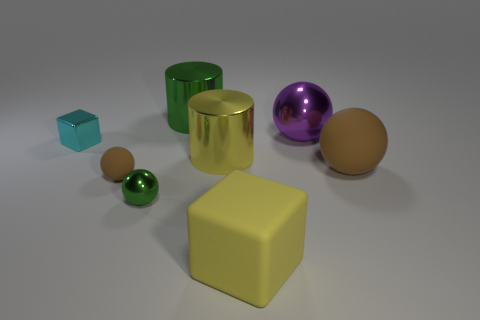What number of objects are things to the right of the big green metal cylinder or tiny green metallic balls?
Your answer should be very brief. 5. Does the big ball behind the big matte ball have the same color as the large matte sphere?
Provide a short and direct response. No. The green metal thing that is behind the ball behind the tiny cyan metallic thing is what shape?
Offer a terse response. Cylinder. Is the number of large purple balls right of the purple thing less than the number of cyan shiny things in front of the metallic block?
Your answer should be very brief. No. There is a green object that is the same shape as the small brown matte thing; what size is it?
Provide a short and direct response. Small. Are there any other things that are the same size as the cyan metal block?
Your answer should be very brief. Yes. How many things are big cylinders that are behind the tiny cyan shiny block or big metal cylinders behind the small cyan metal thing?
Offer a very short reply. 1. Is the size of the cyan metallic object the same as the green ball?
Provide a short and direct response. Yes. Are there more yellow cylinders than tiny yellow shiny blocks?
Your answer should be very brief. Yes. How many other things are there of the same color as the tiny rubber object?
Your answer should be compact. 1. 